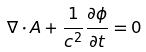<formula> <loc_0><loc_0><loc_500><loc_500>\nabla \cdot A + \frac { 1 } { c ^ { 2 } } \frac { \partial \phi } { \partial t } = 0</formula> 